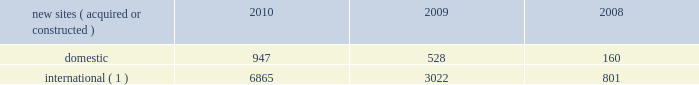2022 international .
In general , our international markets are less advanced with respect to the current technologies deployed for wireless services .
As a result , demand for our communications sites is driven by continued voice network investments , new market entrants and initial 3g data network deployments .
For example , in india , nationwide voice networks continue to be deployed as wireless service providers are beginning their initial investments in 3g data networks , as a result of recent spectrum auctions .
In mexico and brazil , where nationwide voice networks have been deployed , some incumbent wireless service providers continue to invest in their 3g data networks , and recent spectrum auctions have enabled other incumbent wireless service providers and new market entrants to begin their initial investments in 3g data networks .
In markets such as chile and peru , recent spectrum auctions have attracted new market entrants , who are expected to begin their investment in deploying nationwide voice and 3g data networks .
We believe demand for our tower sites will continue in our international markets as wireless service providers seek to remain competitive by increasing the coverage of their networks while also investing in next generation data networks .
Rental and management operations new site revenue growth .
During the year ended december 31 , 2010 , we grew our portfolio of communications sites through acquisitions and construction activities , including the acquisition and construction of approximately 7800 sites .
We continue to evaluate opportunities to acquire larger communications site portfolios , both domestically and internationally , that we believe we can effectively integrate into our existing portfolio. .
( 1 ) the majority of sites acquired or constructed internationally during 2010 and 2009 were in india and our newly launched operations in chile , colombia and peru .
Network development services segment revenue growth .
As we continue to focus on growing our rental and management operations , we anticipate that our network development services revenue will continue to represent a small percentage of our total revenues .
Through our network development services segment , we offer tower-related services , including site acquisition , zoning and permitting services and structural analysis services , which primarily support our site leasing business and the addition of new tenants and equipment on our sites .
Rental and management operations expenses .
Our rental and management operations expenses include our direct site level expenses and consist primarily of ground rent , property taxes , repairs and maintenance and utilities .
These segment level expenses exclude all segment and corporate level selling , general , administrative and development expenses , which are aggregated into one line item entitled selling , general , administrative and development expense .
In general , our rental and management segment level selling , general and administrative expenses do not significantly increase as a result of adding incremental tenants to our legacy sites and typically increase only modestly year-over-year .
As a result , leasing additional space to new tenants on our legacy sites provides significant incremental cash flow .
In geographic areas where we have recently launched operations or are focused on materially expanding our site footprint , we may incur additional segment level selling , general and administrative expenses as we increase our presence in these areas .
Our profit margin growth is therefore positively impacted by the addition of new tenants to our legacy sites and can be temporarily diluted by our development activities .
Reit election .
As we review our tax strategy and assess the utilization of our federal and state nols , we are actively considering an election to a reit for u.s .
Federal and , where applicable , state income tax purposes .
We may make the determination to elect reit status for the taxable year beginning january 1 , 2012 , as early as the second half of 2011 , subject to the approval of our board of directors , although there is no certainty as to the timing of a reit election or whether we will make a reit election at all. .
What portion of the new sites acquired or constructed during 2010 is located outside united states? 
Computations: (6865 / (947 + 6865))
Answer: 0.87878. 